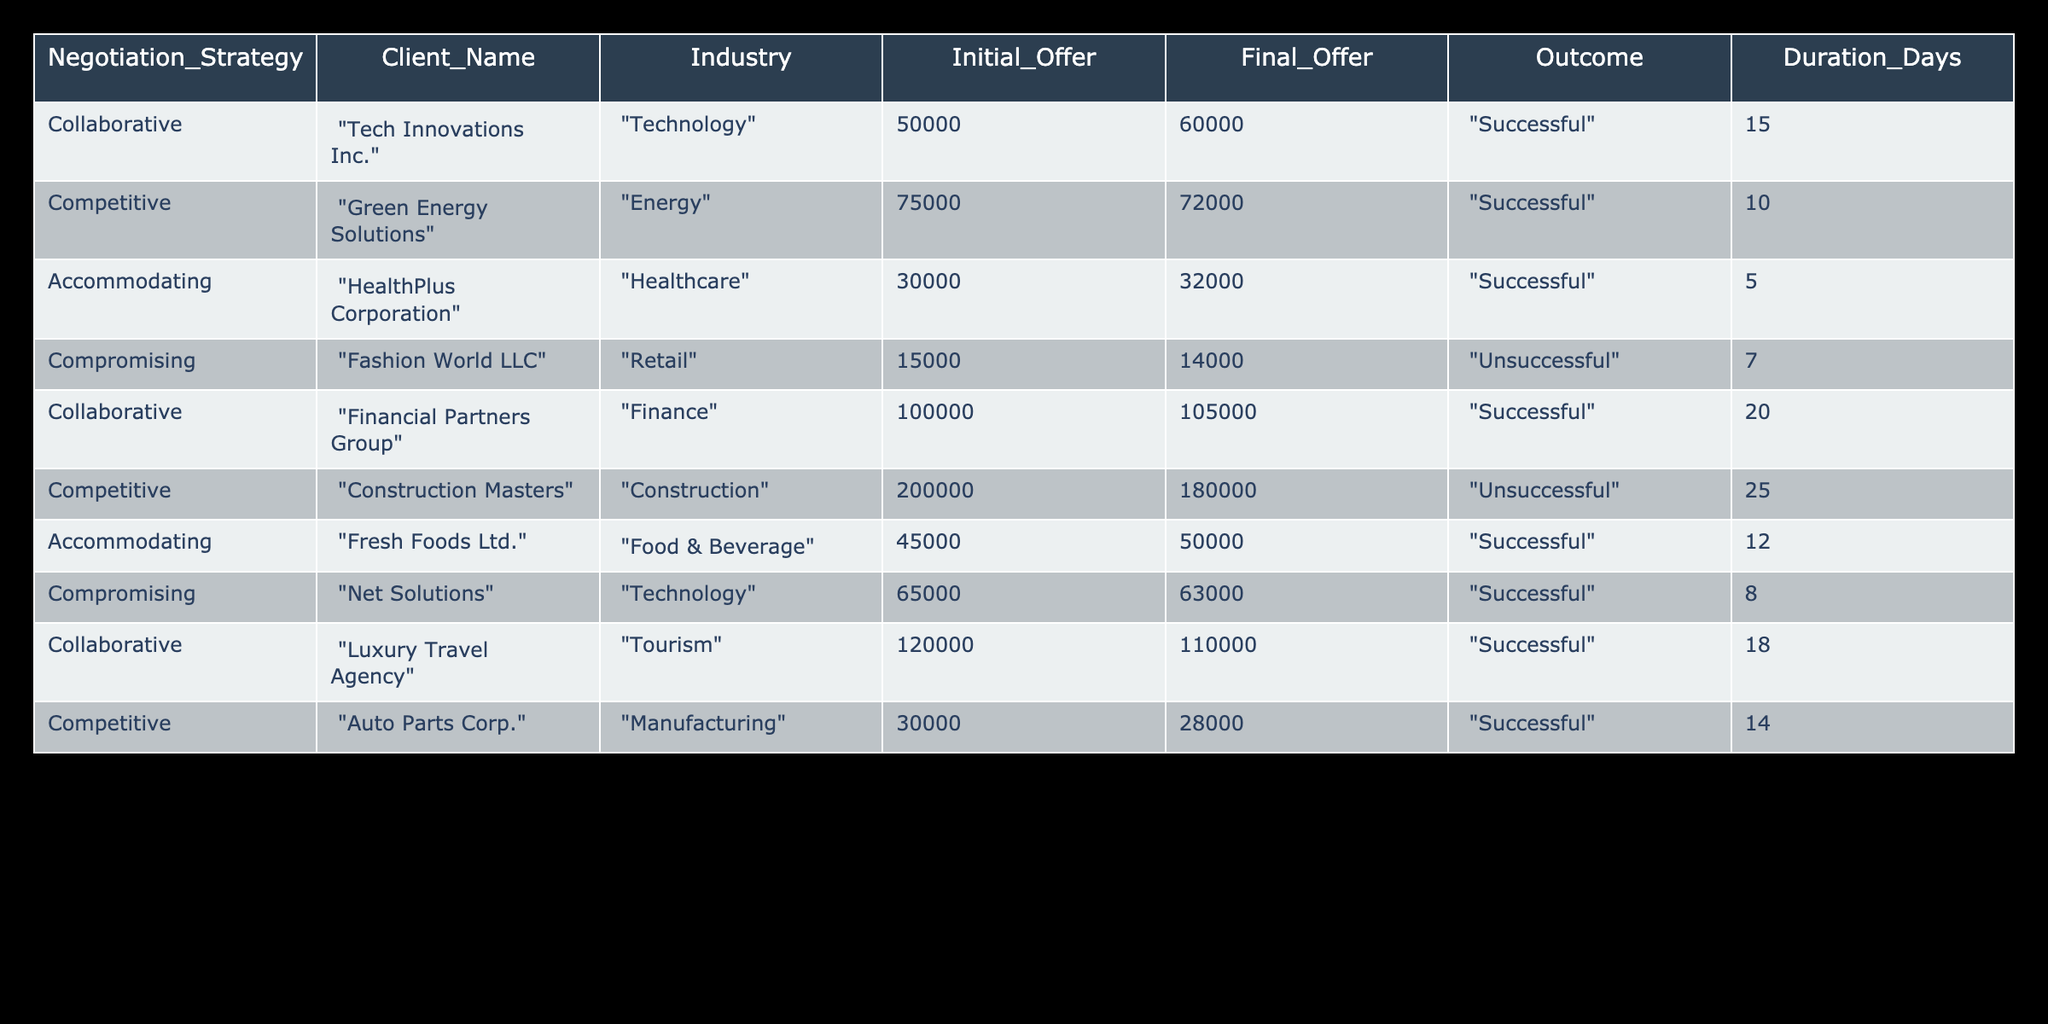What negotiation strategy was used by Auto Parts Corp. in their client interaction? The table shows that Auto Parts Corp. used a "Competitive" negotiation strategy.
Answer: Competitive What was the final offer made to Fashion World LLC? According to the table, the final offer made to Fashion World LLC was 14,000.
Answer: 14,000 Was the negotiation with Fresh Foods Ltd. successful? The outcome column indicates that the negotiation with Fresh Foods Ltd. was "Successful."
Answer: Yes What is the average duration of successful negotiations? To find the average duration of successful negotiations, sum the durations for successful outcomes: (15 + 10 + 5 + 20 + 12 + 14) = 86 days. There are 6 successful negotiations, so the average is 86/6 = 14.33 days.
Answer: 14.33 days Which industry had an unsuccessful negotiation outcome? The table shows that both "Retail" (Fashion World LLC) and "Construction" (Construction Masters) had an unsuccessful negotiation outcome.
Answer: Retail and Construction How much was the final offer different from the initial offer for the negotiation with Tech Innovations Inc.? The initial offer was 50,000 and the final offer was 60,000, which means the difference is 60,000 - 50,000 = 10,000.
Answer: 10,000 How many negotiations had a final offer that was lower than the initial offer? From the table, there are two negotiations (Fashion World LLC and Construction Masters) where the final offer was lower than the initial offer.
Answer: 2 What is the highest initial offer listed in the table? The highest initial offer in the table is 200,000, made by Construction Masters.
Answer: 200,000 What was the most common negotiation strategy used based on the table? By analyzing the table, "Collaborative" was used 3 times while "Competitive," "Accommodating," and "Compromising" were each used 2 times. Thus, the most common strategy is "Collaborative."
Answer: Collaborative 